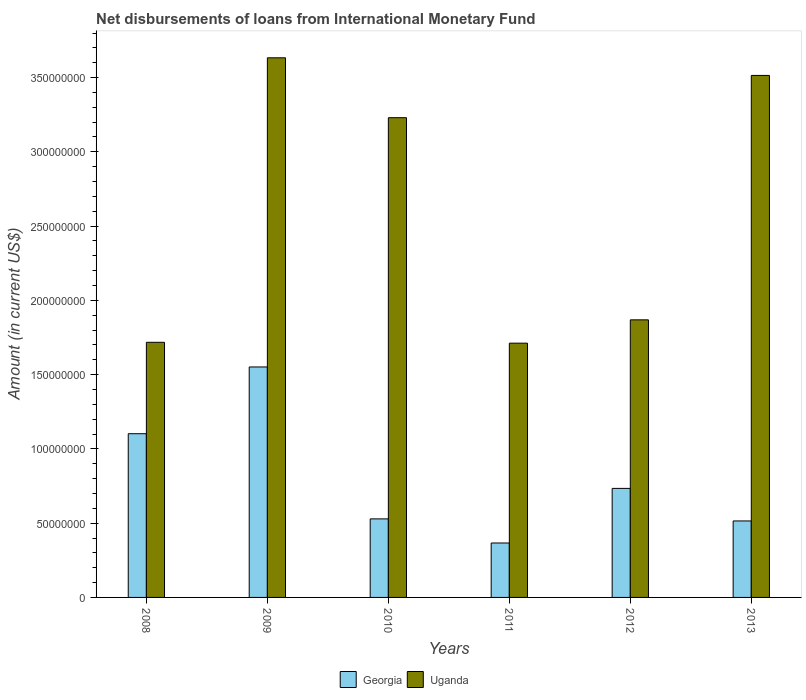How many groups of bars are there?
Ensure brevity in your answer.  6. Are the number of bars per tick equal to the number of legend labels?
Your response must be concise. Yes. How many bars are there on the 4th tick from the left?
Make the answer very short. 2. How many bars are there on the 2nd tick from the right?
Your response must be concise. 2. In how many cases, is the number of bars for a given year not equal to the number of legend labels?
Ensure brevity in your answer.  0. What is the amount of loans disbursed in Uganda in 2012?
Give a very brief answer. 1.87e+08. Across all years, what is the maximum amount of loans disbursed in Georgia?
Your response must be concise. 1.55e+08. Across all years, what is the minimum amount of loans disbursed in Uganda?
Make the answer very short. 1.71e+08. What is the total amount of loans disbursed in Georgia in the graph?
Offer a very short reply. 4.80e+08. What is the difference between the amount of loans disbursed in Georgia in 2010 and that in 2011?
Your answer should be very brief. 1.62e+07. What is the difference between the amount of loans disbursed in Uganda in 2011 and the amount of loans disbursed in Georgia in 2012?
Your response must be concise. 9.78e+07. What is the average amount of loans disbursed in Georgia per year?
Keep it short and to the point. 8.00e+07. In the year 2010, what is the difference between the amount of loans disbursed in Uganda and amount of loans disbursed in Georgia?
Provide a short and direct response. 2.70e+08. What is the ratio of the amount of loans disbursed in Georgia in 2009 to that in 2013?
Provide a short and direct response. 3.01. Is the amount of loans disbursed in Georgia in 2008 less than that in 2012?
Offer a terse response. No. What is the difference between the highest and the second highest amount of loans disbursed in Georgia?
Keep it short and to the point. 4.49e+07. What is the difference between the highest and the lowest amount of loans disbursed in Georgia?
Offer a very short reply. 1.19e+08. In how many years, is the amount of loans disbursed in Georgia greater than the average amount of loans disbursed in Georgia taken over all years?
Your response must be concise. 2. Is the sum of the amount of loans disbursed in Georgia in 2009 and 2012 greater than the maximum amount of loans disbursed in Uganda across all years?
Keep it short and to the point. No. What does the 2nd bar from the left in 2010 represents?
Offer a very short reply. Uganda. What does the 2nd bar from the right in 2013 represents?
Make the answer very short. Georgia. How many bars are there?
Ensure brevity in your answer.  12. How many years are there in the graph?
Make the answer very short. 6. What is the difference between two consecutive major ticks on the Y-axis?
Offer a very short reply. 5.00e+07. Are the values on the major ticks of Y-axis written in scientific E-notation?
Give a very brief answer. No. How are the legend labels stacked?
Your answer should be compact. Horizontal. What is the title of the graph?
Your answer should be compact. Net disbursements of loans from International Monetary Fund. What is the label or title of the Y-axis?
Offer a very short reply. Amount (in current US$). What is the Amount (in current US$) of Georgia in 2008?
Your response must be concise. 1.10e+08. What is the Amount (in current US$) of Uganda in 2008?
Your answer should be compact. 1.72e+08. What is the Amount (in current US$) of Georgia in 2009?
Give a very brief answer. 1.55e+08. What is the Amount (in current US$) in Uganda in 2009?
Provide a succinct answer. 3.63e+08. What is the Amount (in current US$) in Georgia in 2010?
Offer a very short reply. 5.29e+07. What is the Amount (in current US$) of Uganda in 2010?
Your response must be concise. 3.23e+08. What is the Amount (in current US$) of Georgia in 2011?
Make the answer very short. 3.66e+07. What is the Amount (in current US$) of Uganda in 2011?
Ensure brevity in your answer.  1.71e+08. What is the Amount (in current US$) of Georgia in 2012?
Keep it short and to the point. 7.34e+07. What is the Amount (in current US$) of Uganda in 2012?
Your response must be concise. 1.87e+08. What is the Amount (in current US$) in Georgia in 2013?
Offer a terse response. 5.15e+07. What is the Amount (in current US$) in Uganda in 2013?
Keep it short and to the point. 3.51e+08. Across all years, what is the maximum Amount (in current US$) in Georgia?
Your answer should be compact. 1.55e+08. Across all years, what is the maximum Amount (in current US$) in Uganda?
Give a very brief answer. 3.63e+08. Across all years, what is the minimum Amount (in current US$) of Georgia?
Your answer should be very brief. 3.66e+07. Across all years, what is the minimum Amount (in current US$) of Uganda?
Keep it short and to the point. 1.71e+08. What is the total Amount (in current US$) in Georgia in the graph?
Make the answer very short. 4.80e+08. What is the total Amount (in current US$) in Uganda in the graph?
Offer a terse response. 1.57e+09. What is the difference between the Amount (in current US$) in Georgia in 2008 and that in 2009?
Your response must be concise. -4.49e+07. What is the difference between the Amount (in current US$) of Uganda in 2008 and that in 2009?
Provide a succinct answer. -1.92e+08. What is the difference between the Amount (in current US$) of Georgia in 2008 and that in 2010?
Your answer should be compact. 5.73e+07. What is the difference between the Amount (in current US$) in Uganda in 2008 and that in 2010?
Your answer should be very brief. -1.51e+08. What is the difference between the Amount (in current US$) of Georgia in 2008 and that in 2011?
Offer a terse response. 7.36e+07. What is the difference between the Amount (in current US$) of Uganda in 2008 and that in 2011?
Ensure brevity in your answer.  5.75e+05. What is the difference between the Amount (in current US$) of Georgia in 2008 and that in 2012?
Provide a succinct answer. 3.68e+07. What is the difference between the Amount (in current US$) in Uganda in 2008 and that in 2012?
Ensure brevity in your answer.  -1.51e+07. What is the difference between the Amount (in current US$) in Georgia in 2008 and that in 2013?
Give a very brief answer. 5.87e+07. What is the difference between the Amount (in current US$) of Uganda in 2008 and that in 2013?
Provide a short and direct response. -1.80e+08. What is the difference between the Amount (in current US$) of Georgia in 2009 and that in 2010?
Provide a short and direct response. 1.02e+08. What is the difference between the Amount (in current US$) of Uganda in 2009 and that in 2010?
Your response must be concise. 4.03e+07. What is the difference between the Amount (in current US$) of Georgia in 2009 and that in 2011?
Ensure brevity in your answer.  1.19e+08. What is the difference between the Amount (in current US$) of Uganda in 2009 and that in 2011?
Provide a short and direct response. 1.92e+08. What is the difference between the Amount (in current US$) of Georgia in 2009 and that in 2012?
Give a very brief answer. 8.18e+07. What is the difference between the Amount (in current US$) of Uganda in 2009 and that in 2012?
Provide a succinct answer. 1.76e+08. What is the difference between the Amount (in current US$) in Georgia in 2009 and that in 2013?
Provide a succinct answer. 1.04e+08. What is the difference between the Amount (in current US$) in Uganda in 2009 and that in 2013?
Your response must be concise. 1.19e+07. What is the difference between the Amount (in current US$) in Georgia in 2010 and that in 2011?
Ensure brevity in your answer.  1.62e+07. What is the difference between the Amount (in current US$) in Uganda in 2010 and that in 2011?
Your response must be concise. 1.52e+08. What is the difference between the Amount (in current US$) of Georgia in 2010 and that in 2012?
Your response must be concise. -2.05e+07. What is the difference between the Amount (in current US$) of Uganda in 2010 and that in 2012?
Make the answer very short. 1.36e+08. What is the difference between the Amount (in current US$) of Georgia in 2010 and that in 2013?
Offer a very short reply. 1.39e+06. What is the difference between the Amount (in current US$) of Uganda in 2010 and that in 2013?
Offer a very short reply. -2.85e+07. What is the difference between the Amount (in current US$) of Georgia in 2011 and that in 2012?
Your answer should be compact. -3.68e+07. What is the difference between the Amount (in current US$) of Uganda in 2011 and that in 2012?
Provide a succinct answer. -1.57e+07. What is the difference between the Amount (in current US$) in Georgia in 2011 and that in 2013?
Your answer should be compact. -1.48e+07. What is the difference between the Amount (in current US$) of Uganda in 2011 and that in 2013?
Your response must be concise. -1.80e+08. What is the difference between the Amount (in current US$) of Georgia in 2012 and that in 2013?
Provide a succinct answer. 2.19e+07. What is the difference between the Amount (in current US$) in Uganda in 2012 and that in 2013?
Keep it short and to the point. -1.65e+08. What is the difference between the Amount (in current US$) in Georgia in 2008 and the Amount (in current US$) in Uganda in 2009?
Provide a succinct answer. -2.53e+08. What is the difference between the Amount (in current US$) of Georgia in 2008 and the Amount (in current US$) of Uganda in 2010?
Provide a short and direct response. -2.13e+08. What is the difference between the Amount (in current US$) in Georgia in 2008 and the Amount (in current US$) in Uganda in 2011?
Offer a terse response. -6.10e+07. What is the difference between the Amount (in current US$) in Georgia in 2008 and the Amount (in current US$) in Uganda in 2012?
Offer a very short reply. -7.67e+07. What is the difference between the Amount (in current US$) in Georgia in 2008 and the Amount (in current US$) in Uganda in 2013?
Your answer should be compact. -2.41e+08. What is the difference between the Amount (in current US$) of Georgia in 2009 and the Amount (in current US$) of Uganda in 2010?
Your answer should be very brief. -1.68e+08. What is the difference between the Amount (in current US$) of Georgia in 2009 and the Amount (in current US$) of Uganda in 2011?
Give a very brief answer. -1.60e+07. What is the difference between the Amount (in current US$) of Georgia in 2009 and the Amount (in current US$) of Uganda in 2012?
Provide a succinct answer. -3.17e+07. What is the difference between the Amount (in current US$) of Georgia in 2009 and the Amount (in current US$) of Uganda in 2013?
Make the answer very short. -1.96e+08. What is the difference between the Amount (in current US$) in Georgia in 2010 and the Amount (in current US$) in Uganda in 2011?
Provide a succinct answer. -1.18e+08. What is the difference between the Amount (in current US$) in Georgia in 2010 and the Amount (in current US$) in Uganda in 2012?
Offer a terse response. -1.34e+08. What is the difference between the Amount (in current US$) in Georgia in 2010 and the Amount (in current US$) in Uganda in 2013?
Provide a succinct answer. -2.99e+08. What is the difference between the Amount (in current US$) of Georgia in 2011 and the Amount (in current US$) of Uganda in 2012?
Provide a succinct answer. -1.50e+08. What is the difference between the Amount (in current US$) in Georgia in 2011 and the Amount (in current US$) in Uganda in 2013?
Provide a succinct answer. -3.15e+08. What is the difference between the Amount (in current US$) in Georgia in 2012 and the Amount (in current US$) in Uganda in 2013?
Give a very brief answer. -2.78e+08. What is the average Amount (in current US$) of Georgia per year?
Provide a succinct answer. 8.00e+07. What is the average Amount (in current US$) of Uganda per year?
Keep it short and to the point. 2.61e+08. In the year 2008, what is the difference between the Amount (in current US$) of Georgia and Amount (in current US$) of Uganda?
Keep it short and to the point. -6.15e+07. In the year 2009, what is the difference between the Amount (in current US$) of Georgia and Amount (in current US$) of Uganda?
Your response must be concise. -2.08e+08. In the year 2010, what is the difference between the Amount (in current US$) of Georgia and Amount (in current US$) of Uganda?
Keep it short and to the point. -2.70e+08. In the year 2011, what is the difference between the Amount (in current US$) in Georgia and Amount (in current US$) in Uganda?
Offer a very short reply. -1.35e+08. In the year 2012, what is the difference between the Amount (in current US$) in Georgia and Amount (in current US$) in Uganda?
Your response must be concise. -1.13e+08. In the year 2013, what is the difference between the Amount (in current US$) in Georgia and Amount (in current US$) in Uganda?
Keep it short and to the point. -3.00e+08. What is the ratio of the Amount (in current US$) of Georgia in 2008 to that in 2009?
Your answer should be very brief. 0.71. What is the ratio of the Amount (in current US$) of Uganda in 2008 to that in 2009?
Your answer should be very brief. 0.47. What is the ratio of the Amount (in current US$) in Georgia in 2008 to that in 2010?
Your answer should be compact. 2.08. What is the ratio of the Amount (in current US$) of Uganda in 2008 to that in 2010?
Offer a terse response. 0.53. What is the ratio of the Amount (in current US$) in Georgia in 2008 to that in 2011?
Make the answer very short. 3.01. What is the ratio of the Amount (in current US$) in Georgia in 2008 to that in 2012?
Give a very brief answer. 1.5. What is the ratio of the Amount (in current US$) in Uganda in 2008 to that in 2012?
Offer a very short reply. 0.92. What is the ratio of the Amount (in current US$) of Georgia in 2008 to that in 2013?
Offer a very short reply. 2.14. What is the ratio of the Amount (in current US$) of Uganda in 2008 to that in 2013?
Offer a very short reply. 0.49. What is the ratio of the Amount (in current US$) in Georgia in 2009 to that in 2010?
Your answer should be very brief. 2.93. What is the ratio of the Amount (in current US$) in Uganda in 2009 to that in 2010?
Your answer should be compact. 1.12. What is the ratio of the Amount (in current US$) of Georgia in 2009 to that in 2011?
Offer a very short reply. 4.23. What is the ratio of the Amount (in current US$) of Uganda in 2009 to that in 2011?
Give a very brief answer. 2.12. What is the ratio of the Amount (in current US$) of Georgia in 2009 to that in 2012?
Provide a short and direct response. 2.11. What is the ratio of the Amount (in current US$) in Uganda in 2009 to that in 2012?
Provide a succinct answer. 1.94. What is the ratio of the Amount (in current US$) of Georgia in 2009 to that in 2013?
Give a very brief answer. 3.01. What is the ratio of the Amount (in current US$) of Uganda in 2009 to that in 2013?
Provide a succinct answer. 1.03. What is the ratio of the Amount (in current US$) in Georgia in 2010 to that in 2011?
Provide a succinct answer. 1.44. What is the ratio of the Amount (in current US$) in Uganda in 2010 to that in 2011?
Provide a short and direct response. 1.89. What is the ratio of the Amount (in current US$) of Georgia in 2010 to that in 2012?
Provide a succinct answer. 0.72. What is the ratio of the Amount (in current US$) in Uganda in 2010 to that in 2012?
Provide a succinct answer. 1.73. What is the ratio of the Amount (in current US$) of Georgia in 2010 to that in 2013?
Make the answer very short. 1.03. What is the ratio of the Amount (in current US$) in Uganda in 2010 to that in 2013?
Give a very brief answer. 0.92. What is the ratio of the Amount (in current US$) in Georgia in 2011 to that in 2012?
Provide a short and direct response. 0.5. What is the ratio of the Amount (in current US$) of Uganda in 2011 to that in 2012?
Offer a very short reply. 0.92. What is the ratio of the Amount (in current US$) of Georgia in 2011 to that in 2013?
Ensure brevity in your answer.  0.71. What is the ratio of the Amount (in current US$) in Uganda in 2011 to that in 2013?
Your response must be concise. 0.49. What is the ratio of the Amount (in current US$) of Georgia in 2012 to that in 2013?
Your answer should be very brief. 1.43. What is the ratio of the Amount (in current US$) of Uganda in 2012 to that in 2013?
Your response must be concise. 0.53. What is the difference between the highest and the second highest Amount (in current US$) of Georgia?
Ensure brevity in your answer.  4.49e+07. What is the difference between the highest and the second highest Amount (in current US$) of Uganda?
Provide a short and direct response. 1.19e+07. What is the difference between the highest and the lowest Amount (in current US$) of Georgia?
Make the answer very short. 1.19e+08. What is the difference between the highest and the lowest Amount (in current US$) in Uganda?
Offer a very short reply. 1.92e+08. 